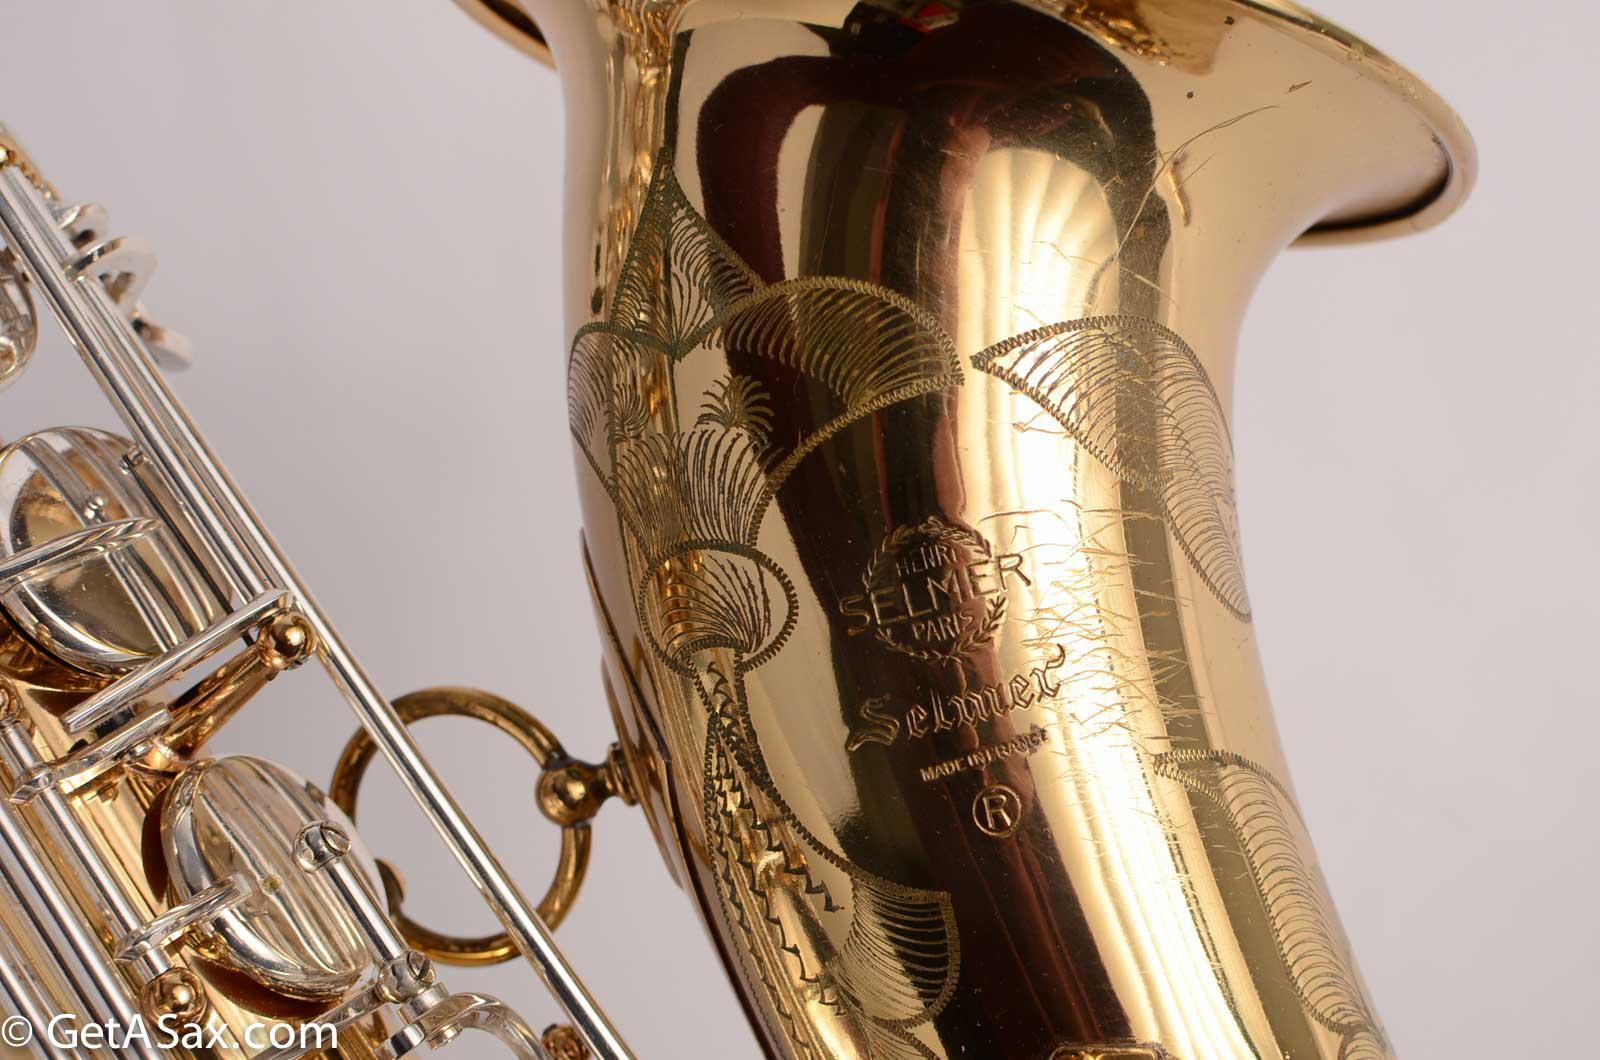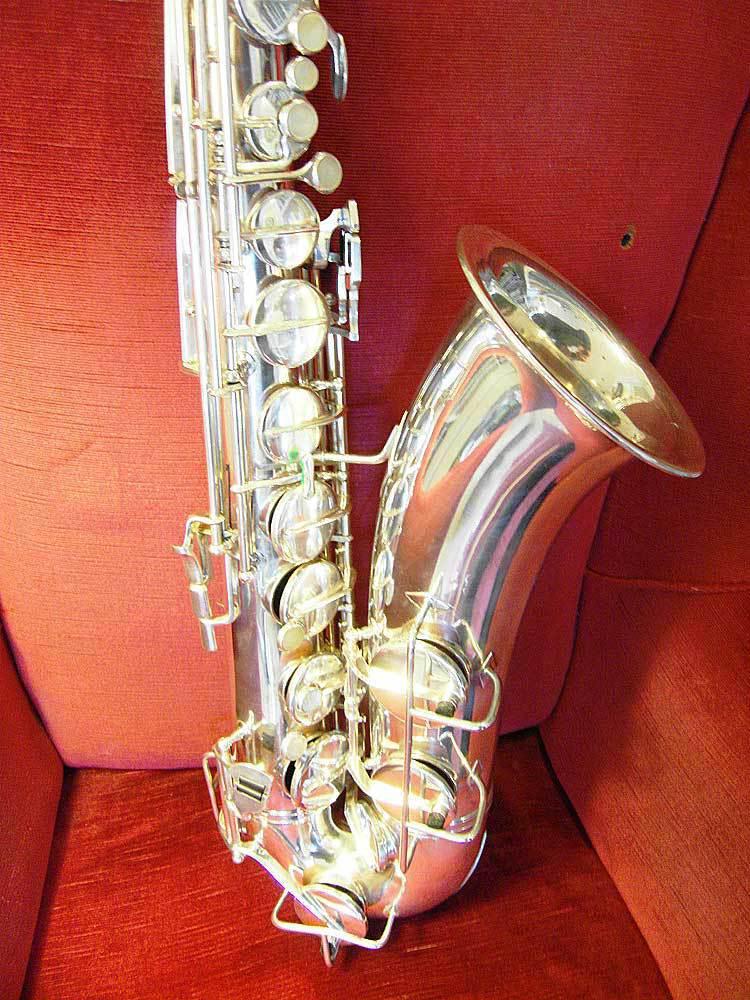The first image is the image on the left, the second image is the image on the right. Considering the images on both sides, is "The image on the right features a silver sax in the upright position." valid? Answer yes or no. Yes. The first image is the image on the left, the second image is the image on the right. Evaluate the accuracy of this statement regarding the images: "At least one image shows a saxophone displayed on a rich orange-red fabric.". Is it true? Answer yes or no. Yes. 